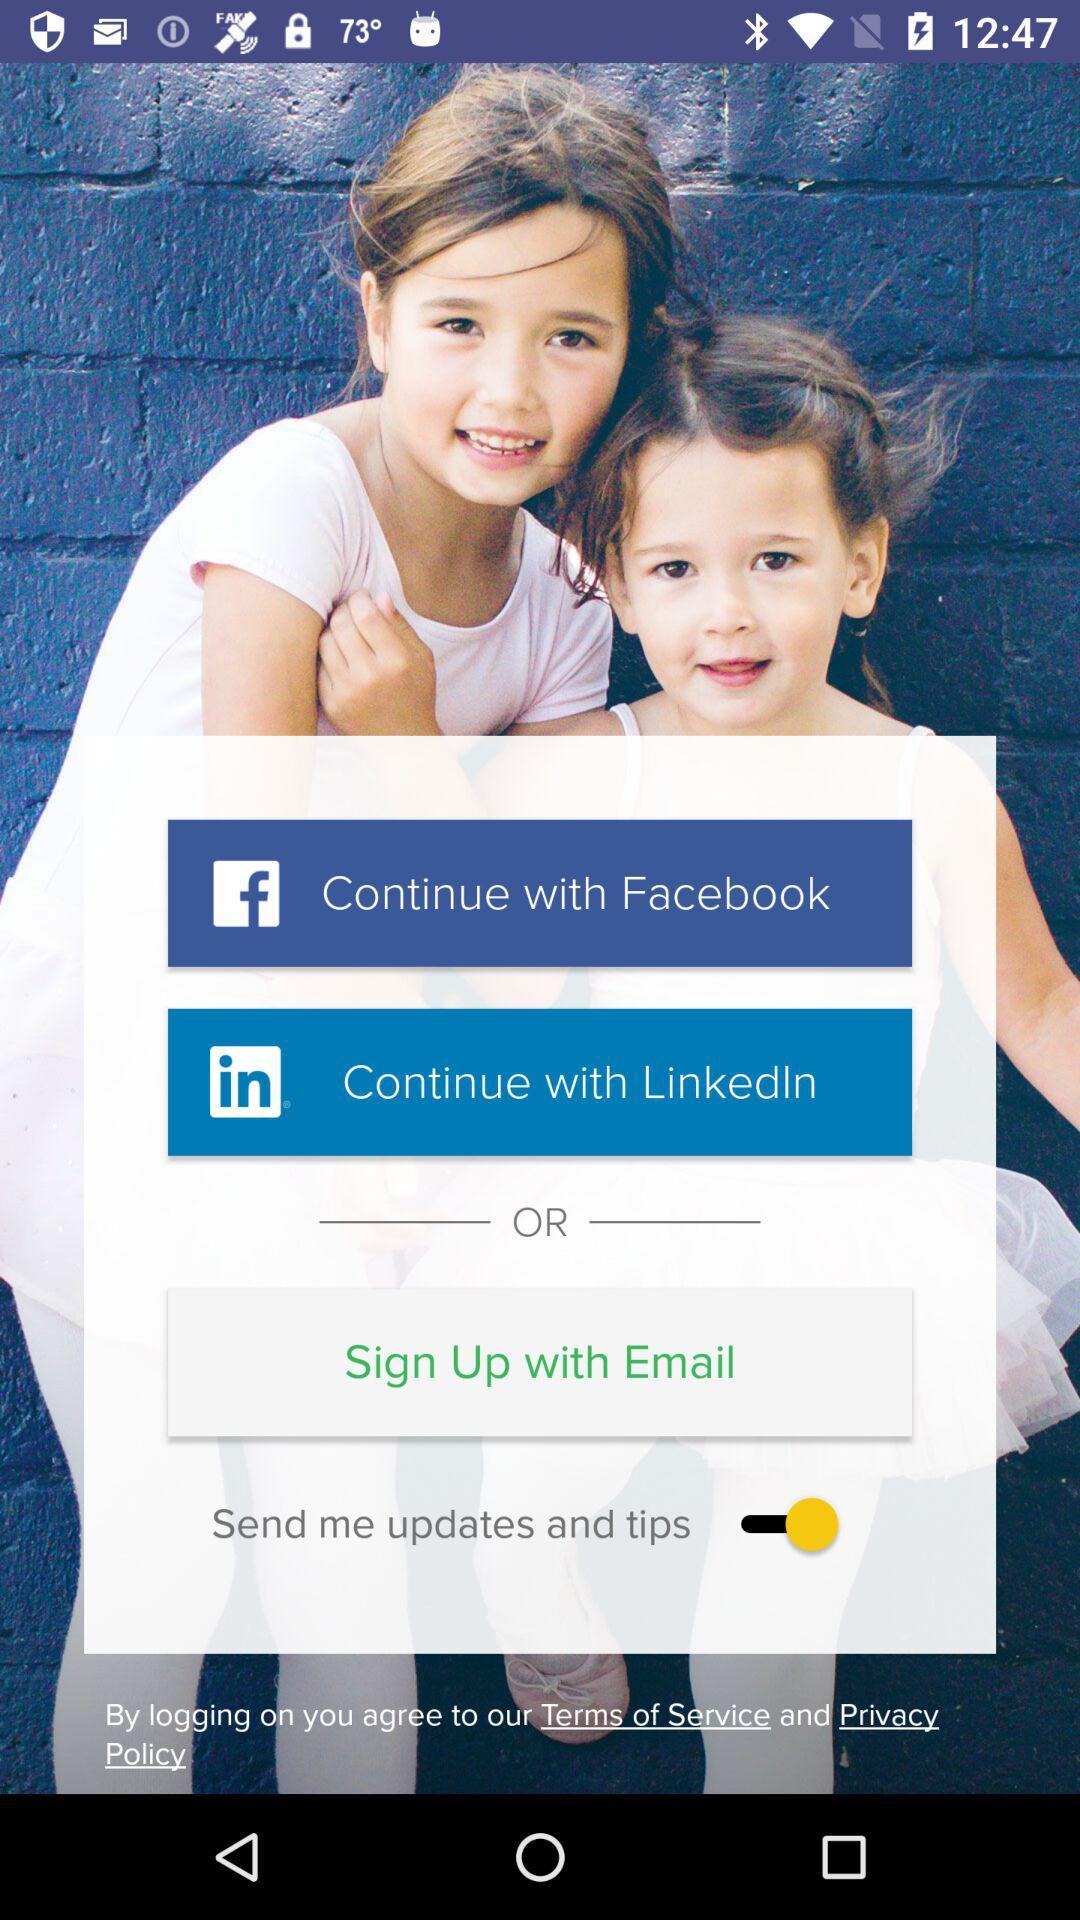What is the status of "Send me updates and tips"? The status of "Send me updates and tips" is "on". 